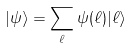Convert formula to latex. <formula><loc_0><loc_0><loc_500><loc_500>| \psi \rangle = \sum _ { \ell } \psi ( \ell ) | \ell \rangle</formula> 